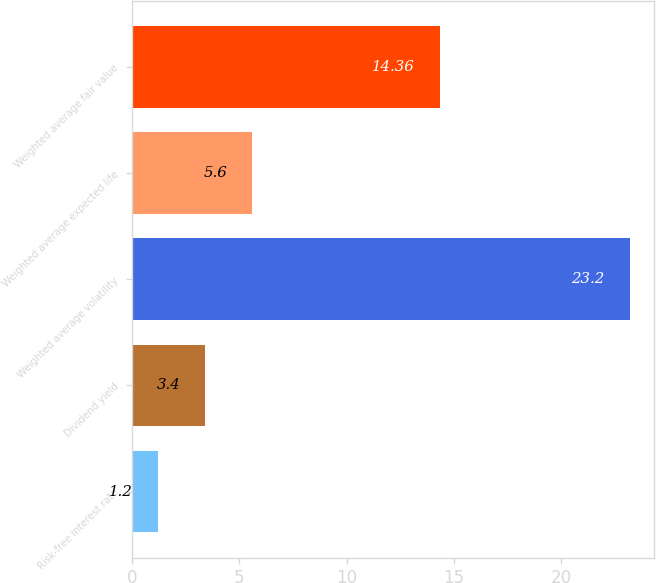<chart> <loc_0><loc_0><loc_500><loc_500><bar_chart><fcel>Risk-free interest rate<fcel>Dividend yield<fcel>Weighted average volatility<fcel>Weighted average expected life<fcel>Weighted average fair value<nl><fcel>1.2<fcel>3.4<fcel>23.2<fcel>5.6<fcel>14.36<nl></chart> 